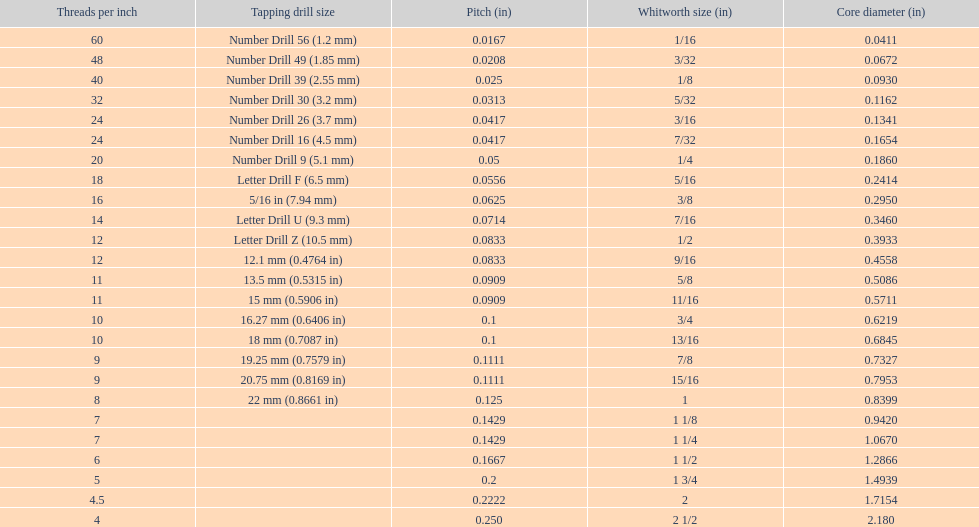What is the total of the first two core diameters? 0.1083. 